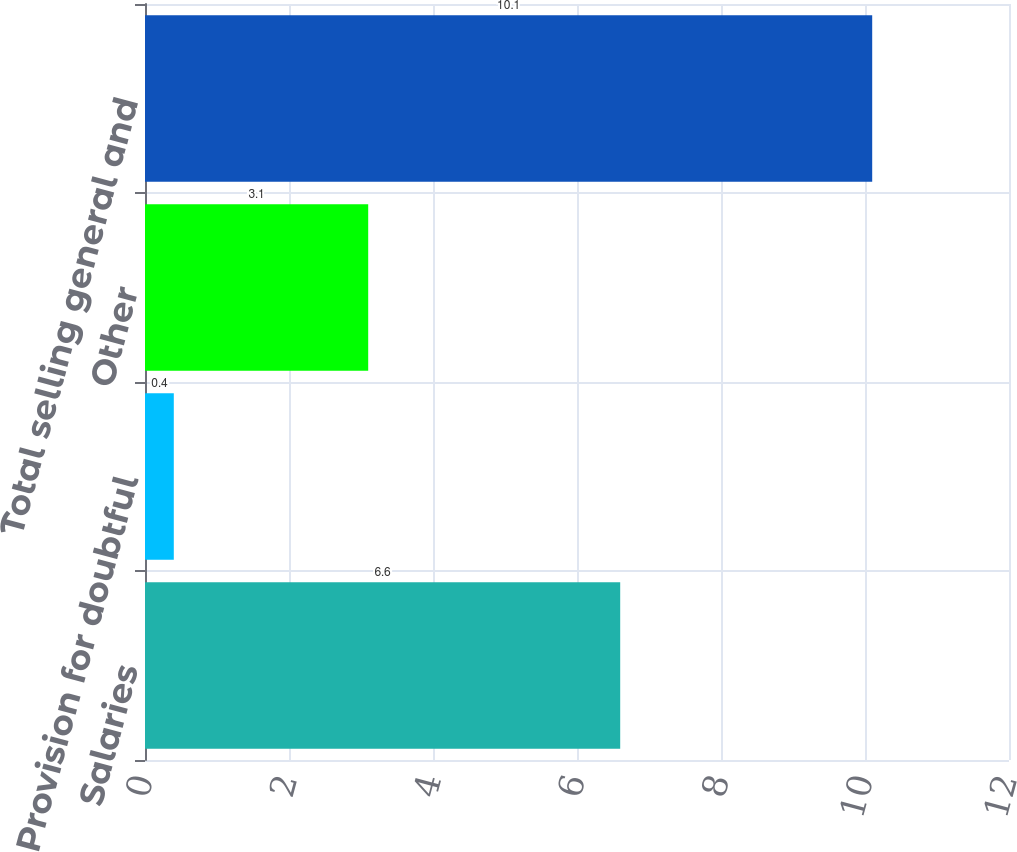Convert chart to OTSL. <chart><loc_0><loc_0><loc_500><loc_500><bar_chart><fcel>Salaries<fcel>Provision for doubtful<fcel>Other<fcel>Total selling general and<nl><fcel>6.6<fcel>0.4<fcel>3.1<fcel>10.1<nl></chart> 